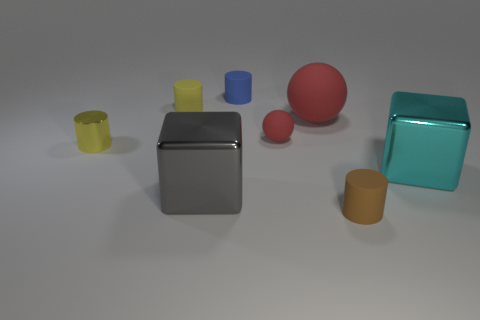Is there any other thing that has the same material as the big red thing?
Offer a terse response. Yes. Are there any other gray metal things of the same shape as the tiny metal thing?
Keep it short and to the point. No. There is a thing that is the same color as the tiny ball; what is its material?
Keep it short and to the point. Rubber. What number of metallic things are either brown cylinders or large spheres?
Provide a succinct answer. 0. What is the shape of the tiny metallic thing?
Your response must be concise. Cylinder. How many yellow objects are the same material as the small red thing?
Ensure brevity in your answer.  1. There is a large thing that is made of the same material as the small brown object; what is its color?
Make the answer very short. Red. There is a yellow metallic thing that is left of the blue matte cylinder; does it have the same size as the big cyan block?
Give a very brief answer. No. The other metallic thing that is the same shape as the blue thing is what color?
Provide a short and direct response. Yellow. There is a large thing behind the object to the right of the tiny cylinder in front of the cyan metallic object; what is its shape?
Your answer should be compact. Sphere. 